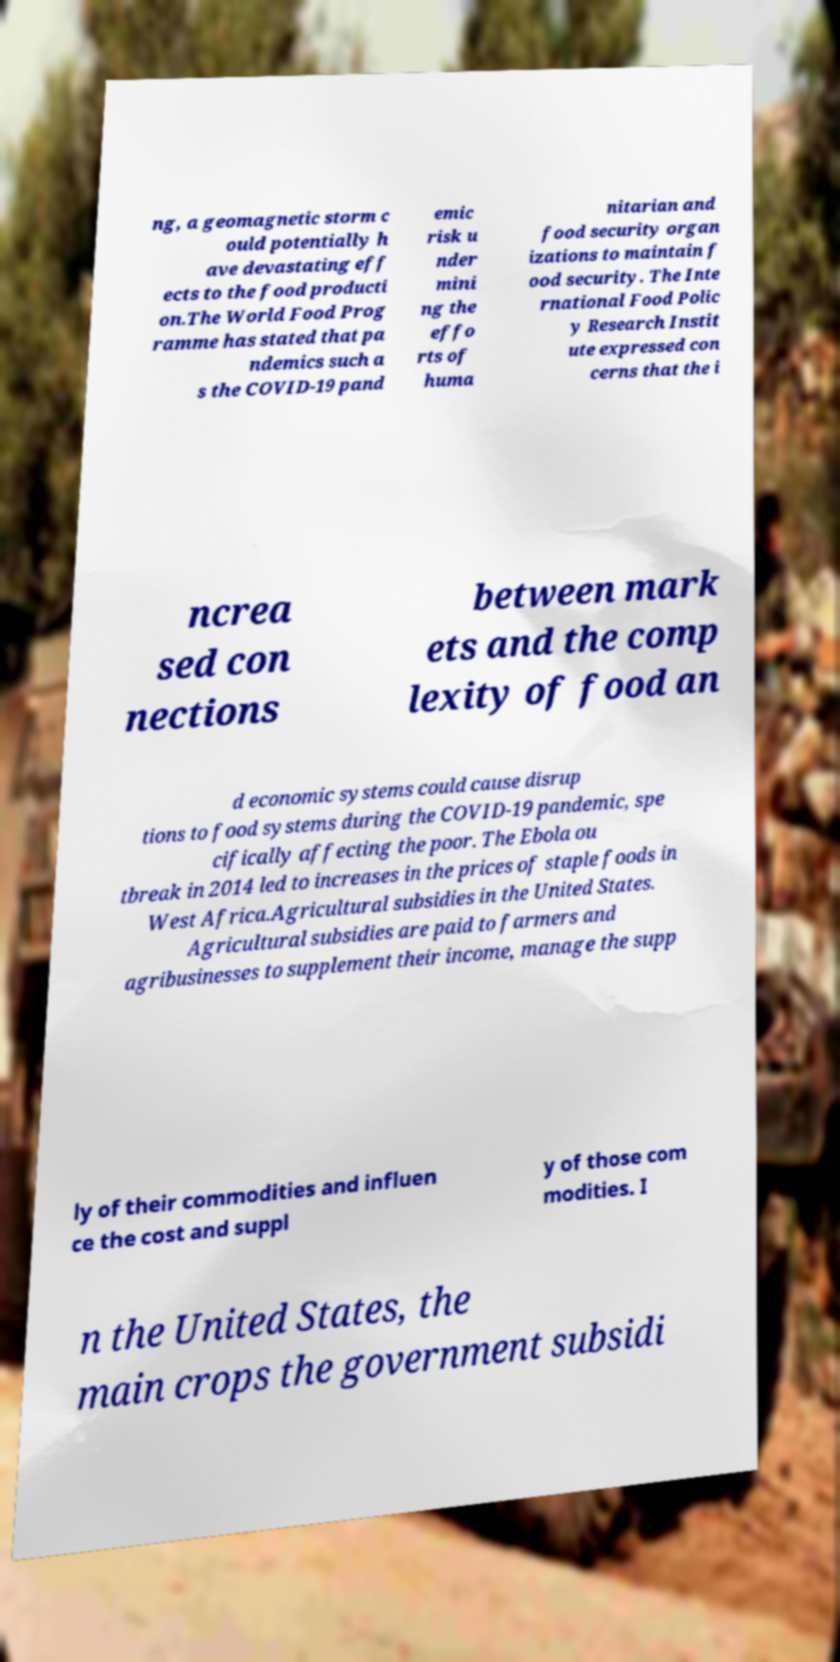Please read and relay the text visible in this image. What does it say? ng, a geomagnetic storm c ould potentially h ave devastating eff ects to the food producti on.The World Food Prog ramme has stated that pa ndemics such a s the COVID-19 pand emic risk u nder mini ng the effo rts of huma nitarian and food security organ izations to maintain f ood security. The Inte rnational Food Polic y Research Instit ute expressed con cerns that the i ncrea sed con nections between mark ets and the comp lexity of food an d economic systems could cause disrup tions to food systems during the COVID-19 pandemic, spe cifically affecting the poor. The Ebola ou tbreak in 2014 led to increases in the prices of staple foods in West Africa.Agricultural subsidies in the United States. Agricultural subsidies are paid to farmers and agribusinesses to supplement their income, manage the supp ly of their commodities and influen ce the cost and suppl y of those com modities. I n the United States, the main crops the government subsidi 